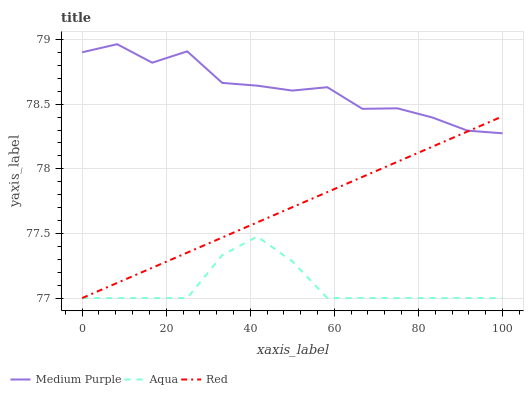Does Red have the minimum area under the curve?
Answer yes or no. No. Does Red have the maximum area under the curve?
Answer yes or no. No. Is Aqua the smoothest?
Answer yes or no. No. Is Aqua the roughest?
Answer yes or no. No. Does Red have the highest value?
Answer yes or no. No. Is Aqua less than Medium Purple?
Answer yes or no. Yes. Is Medium Purple greater than Aqua?
Answer yes or no. Yes. Does Aqua intersect Medium Purple?
Answer yes or no. No. 